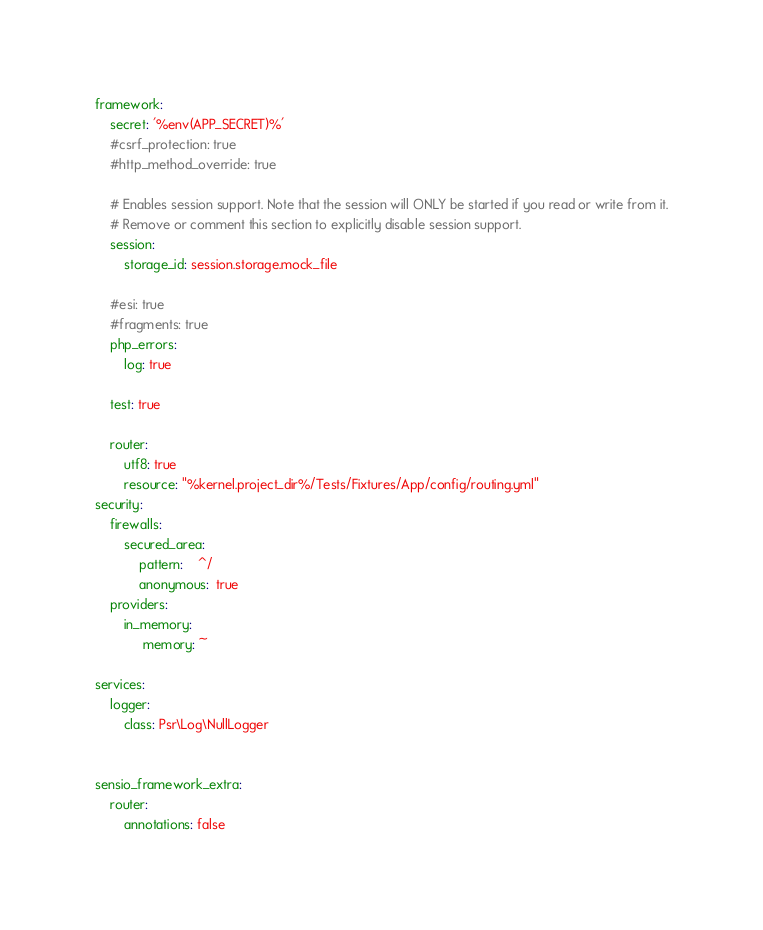Convert code to text. <code><loc_0><loc_0><loc_500><loc_500><_YAML_>framework:
    secret: '%env(APP_SECRET)%'
    #csrf_protection: true
    #http_method_override: true

    # Enables session support. Note that the session will ONLY be started if you read or write from it.
    # Remove or comment this section to explicitly disable session support.
    session:
        storage_id: session.storage.mock_file

    #esi: true
    #fragments: true
    php_errors:
        log: true

    test: true

    router:
        utf8: true
        resource: "%kernel.project_dir%/Tests/Fixtures/App/config/routing.yml"
security:
    firewalls:
        secured_area:
            pattern:    ^/
            anonymous:  true
    providers:
        in_memory:
             memory: ~

services:
    logger:
        class: Psr\Log\NullLogger


sensio_framework_extra:
    router:
        annotations: false</code> 